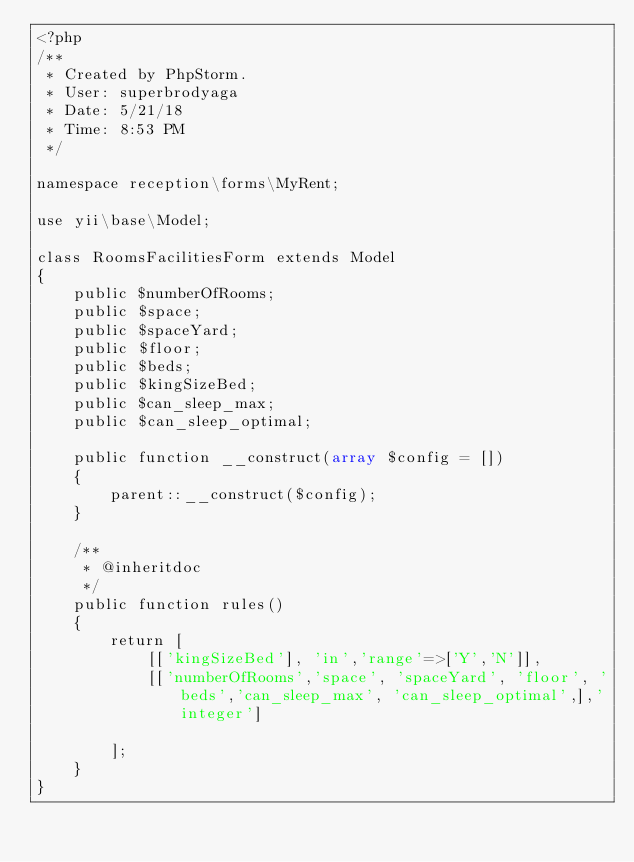<code> <loc_0><loc_0><loc_500><loc_500><_PHP_><?php
/**
 * Created by PhpStorm.
 * User: superbrodyaga
 * Date: 5/21/18
 * Time: 8:53 PM
 */

namespace reception\forms\MyRent;

use yii\base\Model;

class RoomsFacilitiesForm extends Model
{
    public $numberOfRooms;
    public $space;
    public $spaceYard;
    public $floor;
    public $beds;
    public $kingSizeBed;
    public $can_sleep_max;
    public $can_sleep_optimal;

    public function __construct(array $config = [])
    {
        parent::__construct($config);
    }

    /**
     * @inheritdoc
     */
    public function rules()
    {
        return [
            [['kingSizeBed'], 'in','range'=>['Y','N']],
            [['numberOfRooms','space', 'spaceYard', 'floor', 'beds','can_sleep_max', 'can_sleep_optimal',],'integer']

        ];
    }
}</code> 